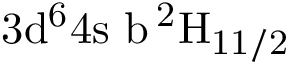<formula> <loc_0><loc_0><loc_500><loc_500>3 d ^ { 6 } 4 s \ b \, ^ { 2 } H _ { 1 1 / 2 }</formula> 